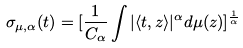Convert formula to latex. <formula><loc_0><loc_0><loc_500><loc_500>\sigma _ { \mu , \alpha } ( t ) = [ \frac { 1 } { C _ { \alpha } } \int | \langle t , z \rangle | ^ { \alpha } d \mu ( z ) ] ^ { \frac { 1 } { \alpha } }</formula> 